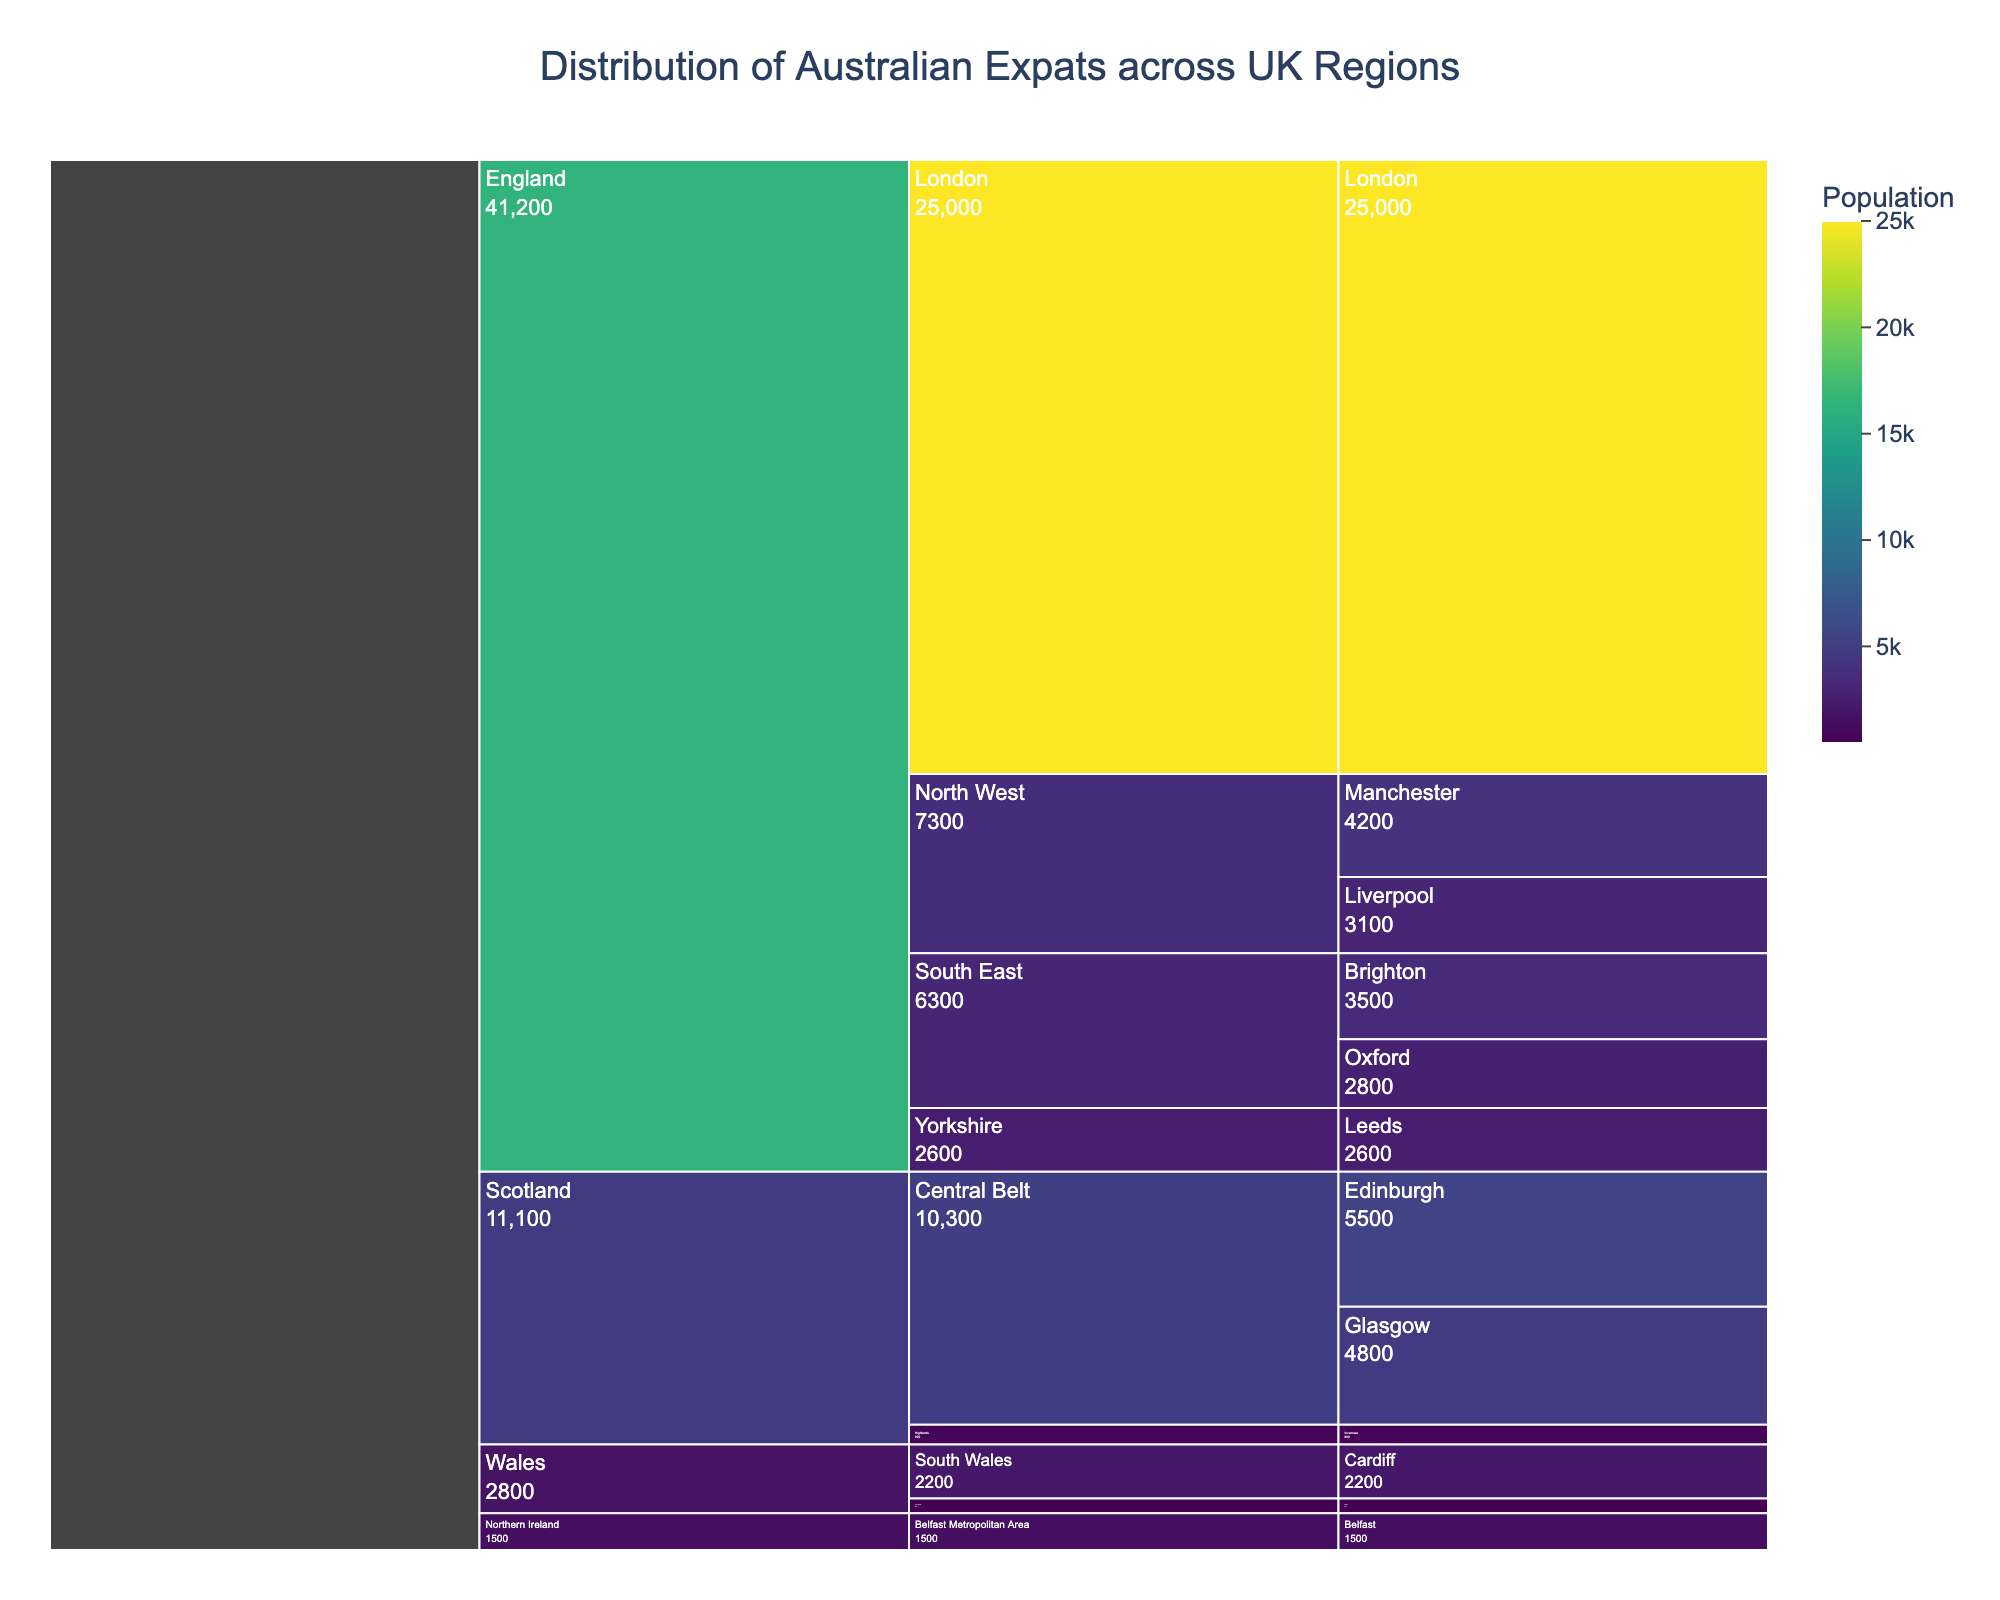Which region has the highest population of Australian expats? The regions listed are England, Scotland, Wales, and Northern Ireland. Comparing the populations for each, we see that England has the highest with London alone having 25,000 people.
Answer: England What's the total population of Australian expats in the South East subregion of England? The cities in South East England are Brighton with 3500 and Oxford with 2800. Adding these gives 3500 + 2800 = 6300.
Answer: 6300 Which city in Scotland has more Australian expats, Edinburgh or Glasgow? Edinburgh's population is 5500, and Glasgow's population is 4800. Comparing these values, Edinburgh has more Australian expats.
Answer: Edinburgh What's the difference between the population of Australian expats in London and the total population in Scotland? London's population is 25,000. In Scotland, adding the populations of Edinburgh (5500), Glasgow (4800), and Inverness (800) gives 5500 + 4800 + 800 = 11,100. The difference is 25,000 - 11,100 = 13,900.
Answer: 13,900 Which city has the least number of Australian expats? Listing all city populations, the lowest is Bangor in North Wales with 600 people.
Answer: Bangor What is the total population of Australian expats in Northern Ireland? There's only one city listed, Belfast, with a population of 1500.
Answer: 1500 How does the population of Australian expats in Northern Ireland compare to Wales? Northern Ireland has 1500 people and Wales has 2200 (Cardiff) + 600 (Bangor) = 2800. Comparatively, Wales has more.
Answer: Wales If I want to live in a city with a medium-sized Australian expat population, which city in England is the best choice? Considering medium-sized populations between 2000 and 5000, Brighton (3500), Oxford (2800), Manchester (4200), Liverpool (3100), and Leeds (2600) are candidates.
Answer: Brighton, Oxford, Manchester, Liverpool, Leeds Which subregion in England has a higher total population of Australian expats, North West or Yorkshire? North West has Manchester (4200) and Liverpool (3100), totalling 4200 + 3100 = 7300. Yorkshire has just Leeds with 2600. Comparing 7300 and 2600, North West has more.
Answer: North West How much higher is the Australian expat population in London compared to Manchester? London's population is 25,000, and Manchester's is 4200. The difference is 25,000 - 4200 = 20,800.
Answer: 20,800 